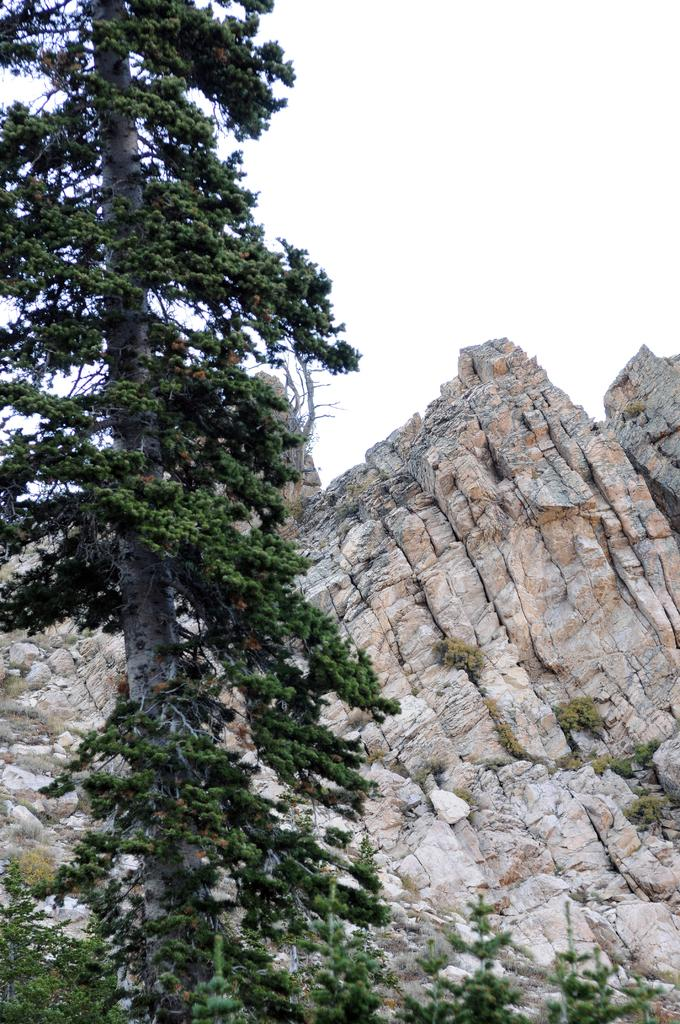What type of natural vegetation is present in the image? There are trees in the image. What type of geographical feature can be seen in the image? There are hills in the image. What part of the natural environment is visible in the image? The sky is visible in the background of the image. What grade does the student receive for their performance in the image? There is no student or performance present in the image, so it is not possible to determine a grade. 